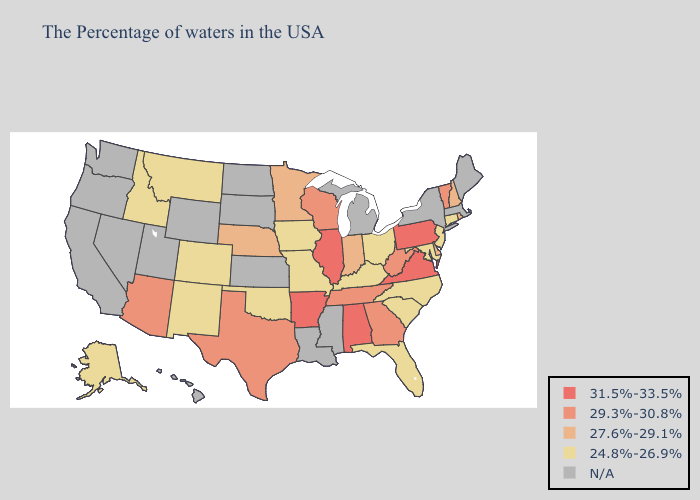Among the states that border Wisconsin , does Illinois have the lowest value?
Be succinct. No. Name the states that have a value in the range 31.5%-33.5%?
Answer briefly. Pennsylvania, Virginia, Alabama, Illinois, Arkansas. Name the states that have a value in the range N/A?
Be succinct. Maine, Massachusetts, New York, Michigan, Mississippi, Louisiana, Kansas, South Dakota, North Dakota, Wyoming, Utah, Nevada, California, Washington, Oregon, Hawaii. What is the highest value in the West ?
Short answer required. 29.3%-30.8%. What is the value of Wyoming?
Concise answer only. N/A. Name the states that have a value in the range N/A?
Write a very short answer. Maine, Massachusetts, New York, Michigan, Mississippi, Louisiana, Kansas, South Dakota, North Dakota, Wyoming, Utah, Nevada, California, Washington, Oregon, Hawaii. Name the states that have a value in the range 27.6%-29.1%?
Quick response, please. Rhode Island, New Hampshire, Delaware, Indiana, Minnesota, Nebraska. How many symbols are there in the legend?
Give a very brief answer. 5. What is the value of Idaho?
Write a very short answer. 24.8%-26.9%. Does Pennsylvania have the highest value in the USA?
Be succinct. Yes. Does the map have missing data?
Short answer required. Yes. Does Arkansas have the highest value in the South?
Answer briefly. Yes. Name the states that have a value in the range 24.8%-26.9%?
Concise answer only. Connecticut, New Jersey, Maryland, North Carolina, South Carolina, Ohio, Florida, Kentucky, Missouri, Iowa, Oklahoma, Colorado, New Mexico, Montana, Idaho, Alaska. 